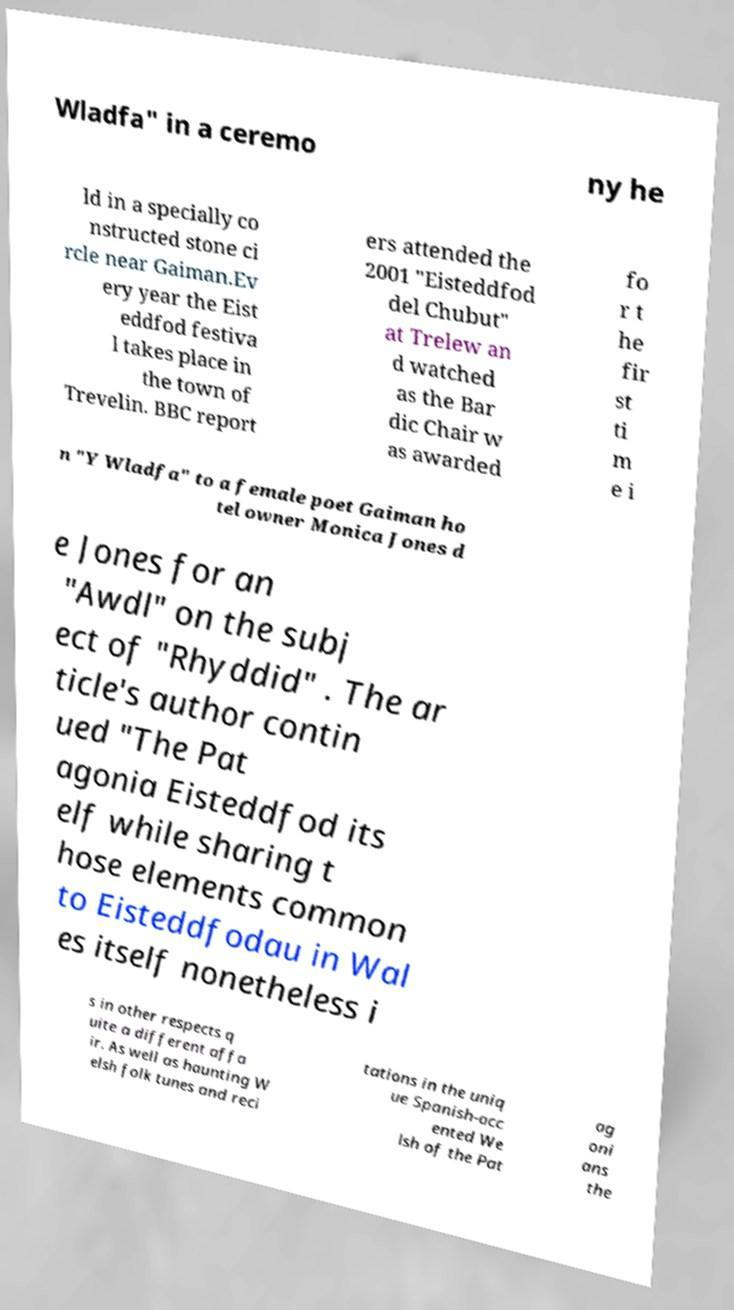Could you assist in decoding the text presented in this image and type it out clearly? Wladfa" in a ceremo ny he ld in a specially co nstructed stone ci rcle near Gaiman.Ev ery year the Eist eddfod festiva l takes place in the town of Trevelin. BBC report ers attended the 2001 "Eisteddfod del Chubut" at Trelew an d watched as the Bar dic Chair w as awarded fo r t he fir st ti m e i n "Y Wladfa" to a female poet Gaiman ho tel owner Monica Jones d e Jones for an "Awdl" on the subj ect of "Rhyddid" . The ar ticle's author contin ued "The Pat agonia Eisteddfod its elf while sharing t hose elements common to Eisteddfodau in Wal es itself nonetheless i s in other respects q uite a different affa ir. As well as haunting W elsh folk tunes and reci tations in the uniq ue Spanish-acc ented We lsh of the Pat ag oni ans the 